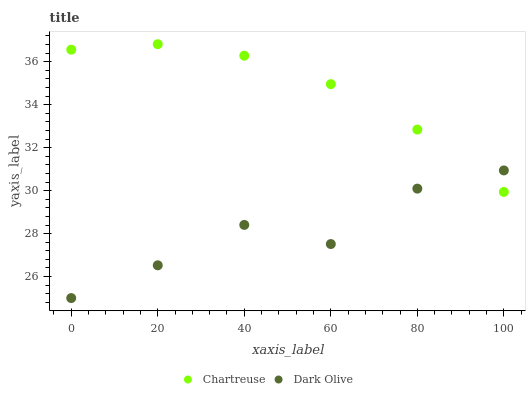Does Dark Olive have the minimum area under the curve?
Answer yes or no. Yes. Does Chartreuse have the maximum area under the curve?
Answer yes or no. Yes. Does Dark Olive have the maximum area under the curve?
Answer yes or no. No. Is Chartreuse the smoothest?
Answer yes or no. Yes. Is Dark Olive the roughest?
Answer yes or no. Yes. Is Dark Olive the smoothest?
Answer yes or no. No. Does Dark Olive have the lowest value?
Answer yes or no. Yes. Does Chartreuse have the highest value?
Answer yes or no. Yes. Does Dark Olive have the highest value?
Answer yes or no. No. Does Chartreuse intersect Dark Olive?
Answer yes or no. Yes. Is Chartreuse less than Dark Olive?
Answer yes or no. No. Is Chartreuse greater than Dark Olive?
Answer yes or no. No. 